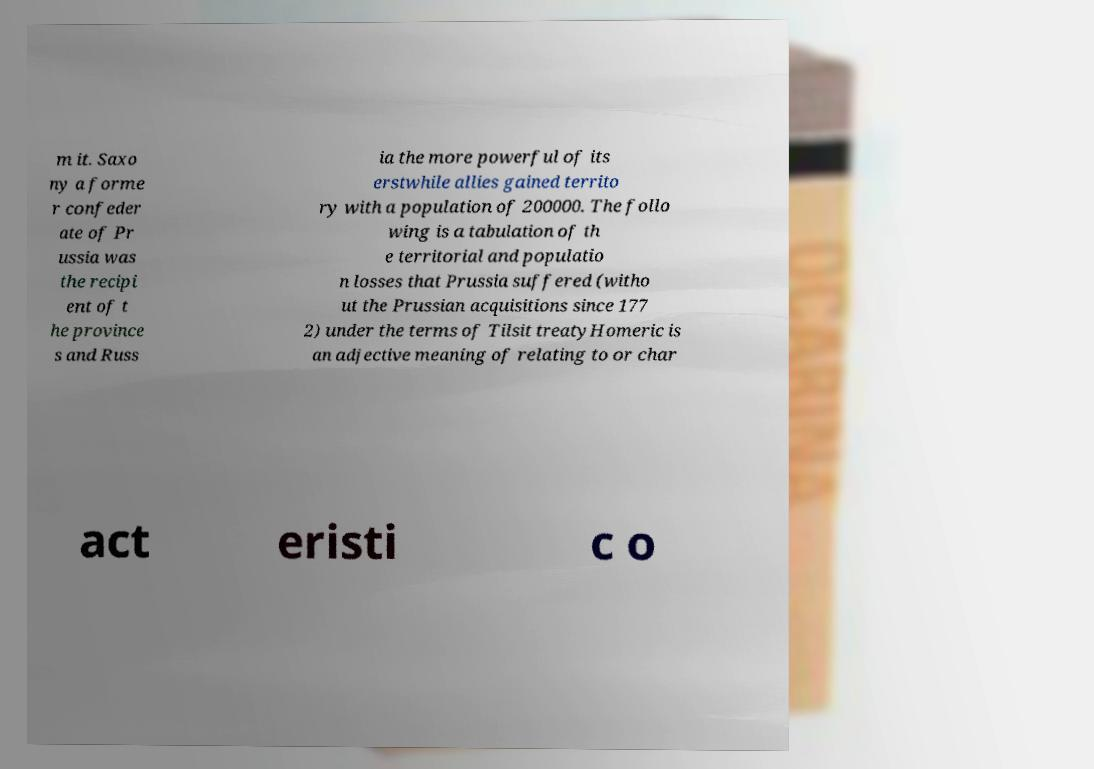There's text embedded in this image that I need extracted. Can you transcribe it verbatim? m it. Saxo ny a forme r confeder ate of Pr ussia was the recipi ent of t he province s and Russ ia the more powerful of its erstwhile allies gained territo ry with a population of 200000. The follo wing is a tabulation of th e territorial and populatio n losses that Prussia suffered (witho ut the Prussian acquisitions since 177 2) under the terms of Tilsit treatyHomeric is an adjective meaning of relating to or char act eristi c o 